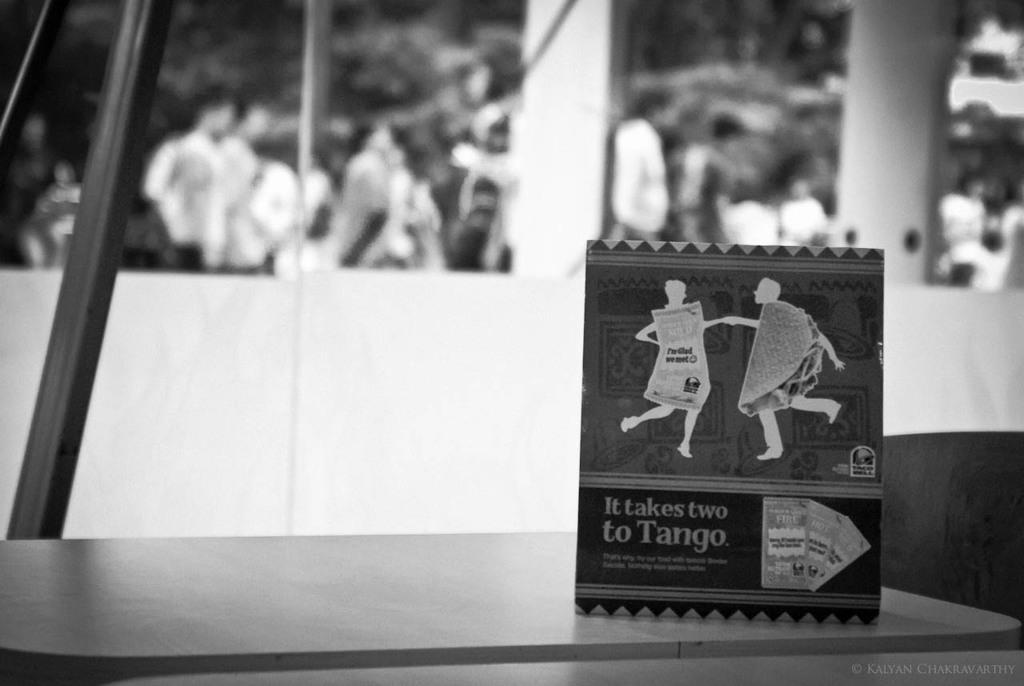What is the color scheme of the image? The image is black and white. What can be seen on the table in the foreground of the image? There is a small poster on a table in the foreground of the image. Can you see any waves crashing on the shore in the image? There are no waves or shore visible in the image, as it is a black and white image with a small poster on a table in the foreground. 